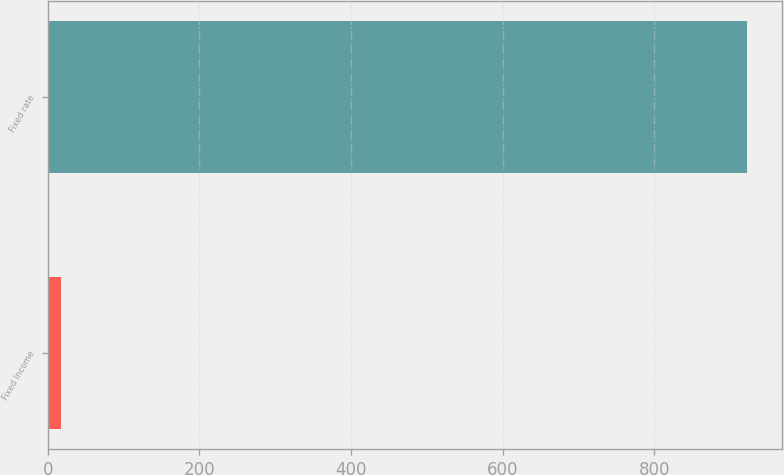<chart> <loc_0><loc_0><loc_500><loc_500><bar_chart><fcel>Fixed Income<fcel>Fixed rate<nl><fcel>17<fcel>923<nl></chart> 